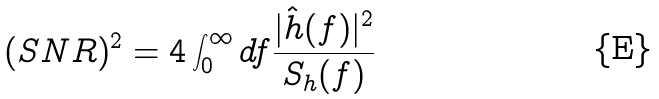Convert formula to latex. <formula><loc_0><loc_0><loc_500><loc_500>( S N R ) ^ { 2 } = 4 \int _ { 0 } ^ { \infty } d f \frac { | \hat { h } ( f ) | ^ { 2 } } { S _ { h } ( f ) }</formula> 